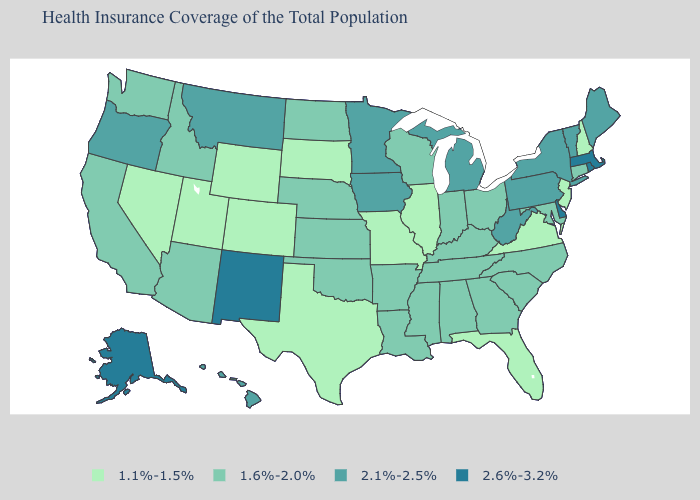Is the legend a continuous bar?
Be succinct. No. What is the lowest value in states that border Oregon?
Answer briefly. 1.1%-1.5%. What is the highest value in the USA?
Keep it brief. 2.6%-3.2%. Name the states that have a value in the range 1.1%-1.5%?
Keep it brief. Colorado, Florida, Illinois, Missouri, Nevada, New Hampshire, New Jersey, South Dakota, Texas, Utah, Virginia, Wyoming. Name the states that have a value in the range 1.1%-1.5%?
Quick response, please. Colorado, Florida, Illinois, Missouri, Nevada, New Hampshire, New Jersey, South Dakota, Texas, Utah, Virginia, Wyoming. Name the states that have a value in the range 2.1%-2.5%?
Concise answer only. Hawaii, Iowa, Maine, Michigan, Minnesota, Montana, New York, Oregon, Pennsylvania, Vermont, West Virginia. Does Virginia have the lowest value in the South?
Answer briefly. Yes. Does Texas have the lowest value in the South?
Be succinct. Yes. How many symbols are there in the legend?
Answer briefly. 4. Among the states that border Florida , which have the highest value?
Keep it brief. Alabama, Georgia. What is the lowest value in states that border Montana?
Write a very short answer. 1.1%-1.5%. Does Alaska have the highest value in the USA?
Concise answer only. Yes. Among the states that border Alabama , which have the highest value?
Write a very short answer. Georgia, Mississippi, Tennessee. Which states have the lowest value in the MidWest?
Write a very short answer. Illinois, Missouri, South Dakota. 